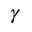<formula> <loc_0><loc_0><loc_500><loc_500>\gamma</formula> 